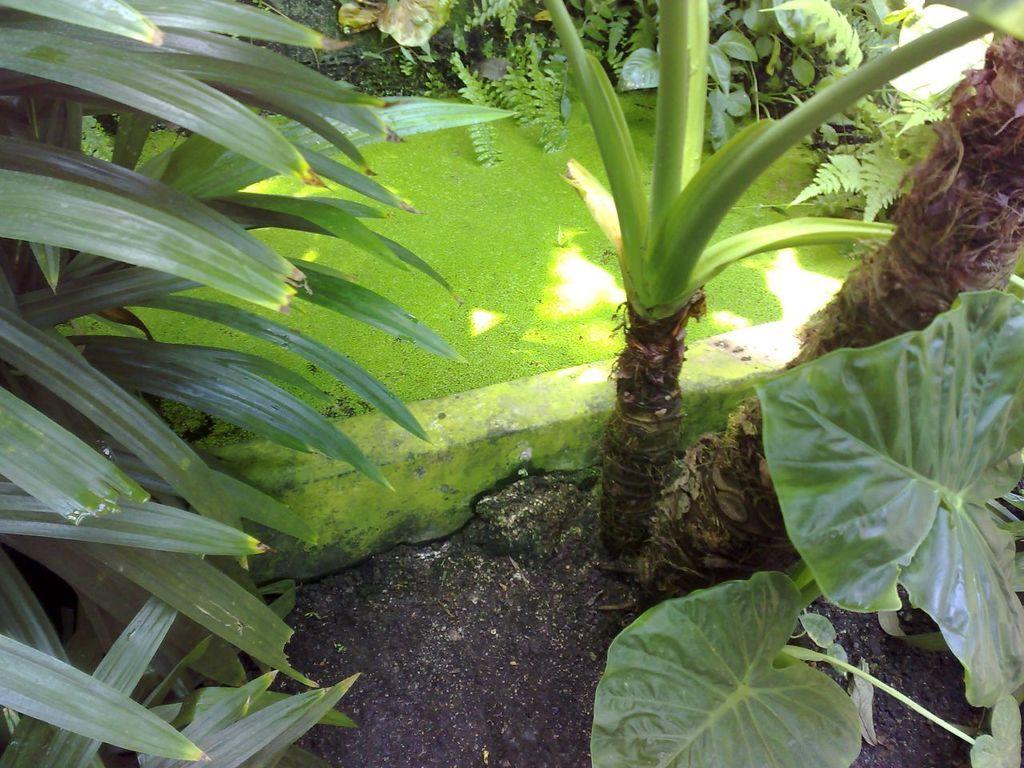In one or two sentences, can you explain what this image depicts? At the bottom of the picture, we see the soil. On the right side, we see the plants. On the left side, we see the shrubs. In the middle, we see the algae in the water. There are trees and plants in the background. 